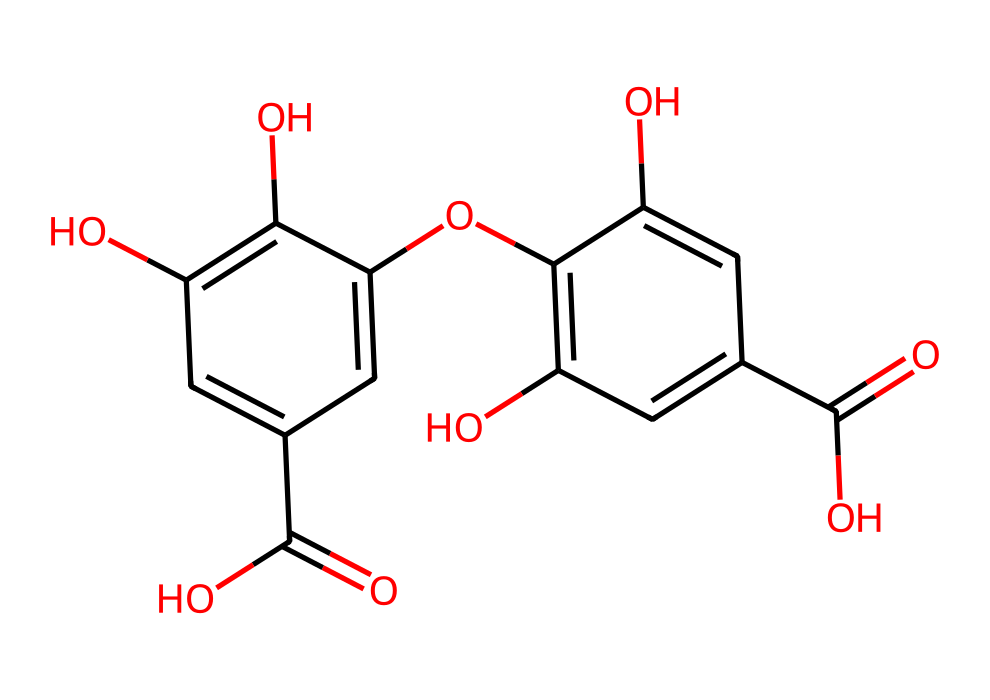How many hydroxyl groups are present in this molecule? The chemical structure shows multiple -OH groups (hydroxyl groups) directly attached to the benzene rings. Counting them visually, there are four -OH groups in total.
Answer: four What is the total number of carbon atoms in the molecule? By examining the structure, count each carbon atom present: there are ten carbon atoms in the main structure, including those part of the aromatic rings.
Answer: ten Which functional groups are present in this chemical? The structure contains carboxylic acid groups (-COOH) and hydroxyl groups (-OH). By identifying the parts of the structure that correspond to these groups, we can confirm their presence.
Answer: carboxylic acid, hydroxyl What type of aromatic compound is this molecule categorized as? This molecule has multiple hydroxyl groups attached to its aromatic rings, making it a polyphenolic compound commonly found in tannins. This classification is based on the presence of multiple aromatic rings and phenolic structures.
Answer: polyphenolic How many rings are present in the structure? The visual structure shows two interconnected benzene rings, which means there are two distinctive ring structures present.
Answer: two Which part of the structure contributes to its tart flavor? The carboxylic acid groups (-COOH) in the structure contribute to its tart flavor. These groups are known to impart acidity, which is often related to tartness in beverages like whiskey.
Answer: carboxylic acid groups 